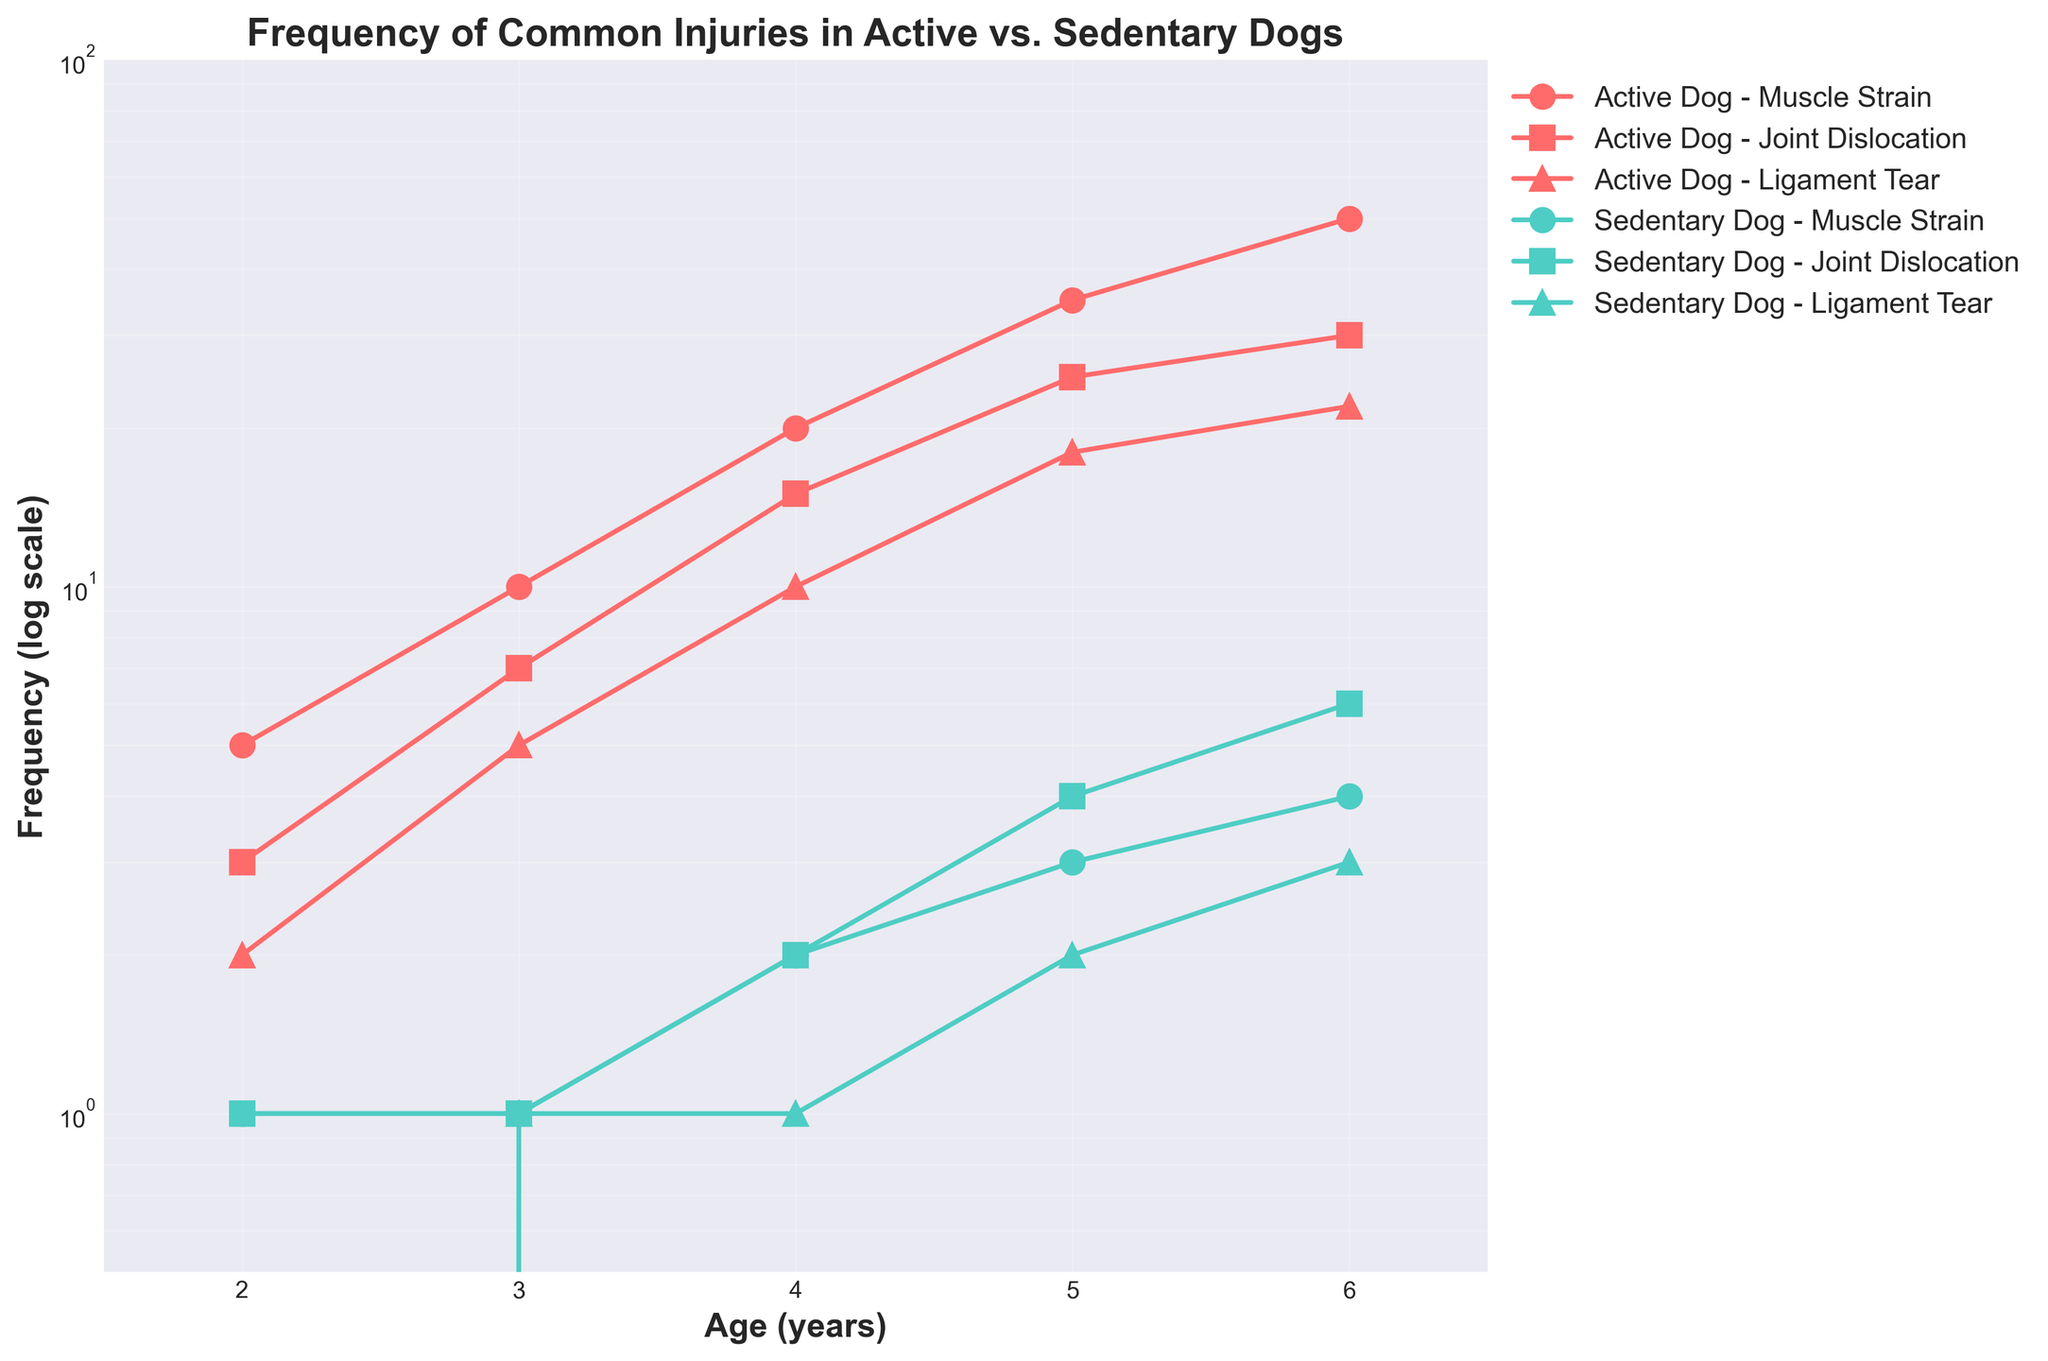what is the title of the figure? The title is displayed at the top of the figure.
Answer: Frequency of Common Injuries in Active vs. Sedentary Dogs What does the y-axis represent? The y-axis label is "Frequency (log scale)", representing the frequency of injuries on a logarithmic scale.
Answer: Frequency (log scale) Which dog type has a higher frequency of muscle strain injuries by the age of 6? Compare the "Active Dog - Muscle Strain" and "Sedentary Dog - Muscle Strain" lines at age 6. Active Dog's frequency is 50, and Sedentary Dog's frequency is 4.
Answer: Active Dog At what age do active dogs experience the most significant increase in joint dislocations frequency? Look for the steepest slope in the "Active Dog - Joint Dislocation" line. The steepest increase occurs between ages 4 and 5.
Answer: Between 4 and 5 how many types of injuries are included in the figure? There are three lines labeled with different markers for each dog type.
Answer: Three Which dog type and injury type has the lowest starting frequency at age 2? Compare the frequency values at age 2 across all lines. "Sedentary Dog - Ligament Tear" starts at 0.
Answer: Sedentary Dog - Ligament Tear What is the maximum frequency of ligament tear injuries for active dogs, and at what age does it occur? Check the "Active Dog - Ligament Tear" line and find the highest y-value, which is 22 at age 6.
Answer: 22 at age 6 What is the trend of muscle strain injuries in sedentary dogs over their lifespan? Follow the "Sedentary Dog - Muscle Strain" line from age 2 to 6. It shows a gradual increase.
Answer: Gradual increase How does the frequency of joint dislocations in sedentary dogs change between ages 4 and 6? Check the "Sedentary Dog - Joint Dislocation" line between ages 4 and 6. It increases from 2 to 6.
Answer: Increases What pattern do ligament tear injuries in active dogs follow from age 3 to 5? Observe the "Active Dog - Ligament Tear" line between ages 3 and 5. The frequency goes from 5 to 18, indicating a noticeable increase.
Answer: Noticable increase 